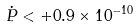<formula> <loc_0><loc_0><loc_500><loc_500>\dot { P } < + 0 . 9 \times 1 0 ^ { - 1 0 }</formula> 